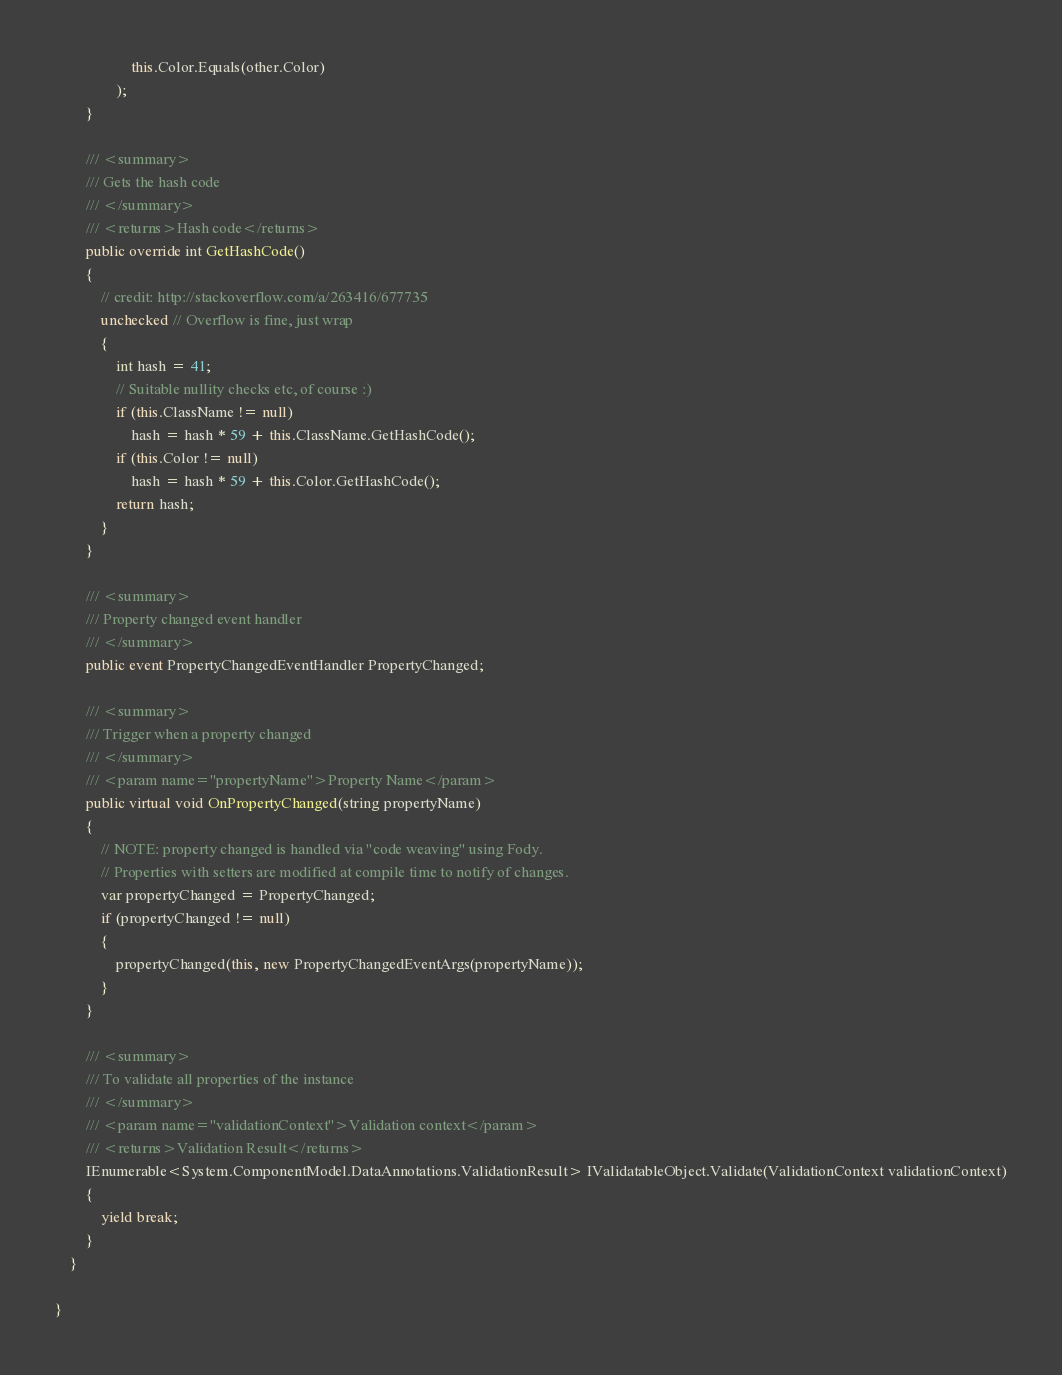Convert code to text. <code><loc_0><loc_0><loc_500><loc_500><_C#_>                    this.Color.Equals(other.Color)
                );
        }

        /// <summary>
        /// Gets the hash code
        /// </summary>
        /// <returns>Hash code</returns>
        public override int GetHashCode()
        {
            // credit: http://stackoverflow.com/a/263416/677735
            unchecked // Overflow is fine, just wrap
            {
                int hash = 41;
                // Suitable nullity checks etc, of course :)
                if (this.ClassName != null)
                    hash = hash * 59 + this.ClassName.GetHashCode();
                if (this.Color != null)
                    hash = hash * 59 + this.Color.GetHashCode();
                return hash;
            }
        }

        /// <summary>
        /// Property changed event handler
        /// </summary>
        public event PropertyChangedEventHandler PropertyChanged;

        /// <summary>
        /// Trigger when a property changed
        /// </summary>
        /// <param name="propertyName">Property Name</param>
        public virtual void OnPropertyChanged(string propertyName)
        {
            // NOTE: property changed is handled via "code weaving" using Fody.
            // Properties with setters are modified at compile time to notify of changes.
            var propertyChanged = PropertyChanged;
            if (propertyChanged != null)
            {
                propertyChanged(this, new PropertyChangedEventArgs(propertyName));
            }
        }

        /// <summary>
        /// To validate all properties of the instance
        /// </summary>
        /// <param name="validationContext">Validation context</param>
        /// <returns>Validation Result</returns>
        IEnumerable<System.ComponentModel.DataAnnotations.ValidationResult> IValidatableObject.Validate(ValidationContext validationContext)
        { 
            yield break;
        }
    }

}
</code> 